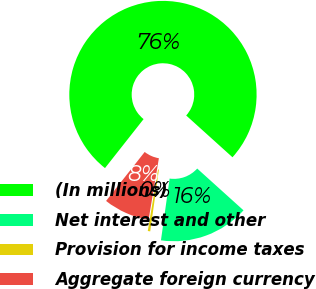Convert chart. <chart><loc_0><loc_0><loc_500><loc_500><pie_chart><fcel>(In millions)<fcel>Net interest and other<fcel>Provision for income taxes<fcel>Aggregate foreign currency<nl><fcel>76.06%<fcel>15.54%<fcel>0.42%<fcel>7.98%<nl></chart> 